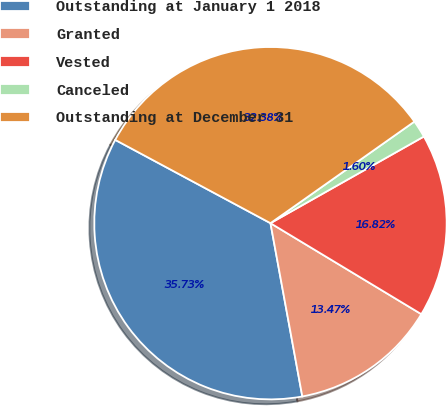Convert chart. <chart><loc_0><loc_0><loc_500><loc_500><pie_chart><fcel>Outstanding at January 1 2018<fcel>Granted<fcel>Vested<fcel>Canceled<fcel>Outstanding at December 31<nl><fcel>35.73%<fcel>13.47%<fcel>16.82%<fcel>1.6%<fcel>32.38%<nl></chart> 